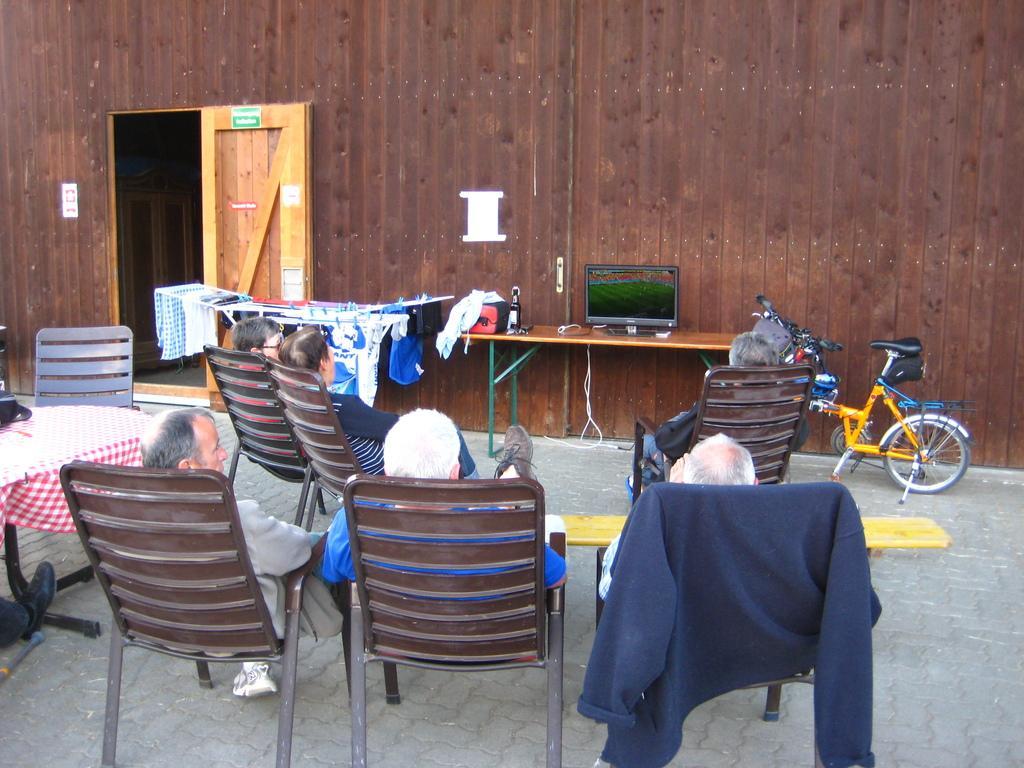Can you describe this image briefly? In this picture we can see a wall and a door, and beside there are some clothes, and here is the table and a wine bottle on it, and here is the computer on the table, here are some bicycles, and person sitting on a chair, and there are group of people ,and here is the table and cloth on it. 